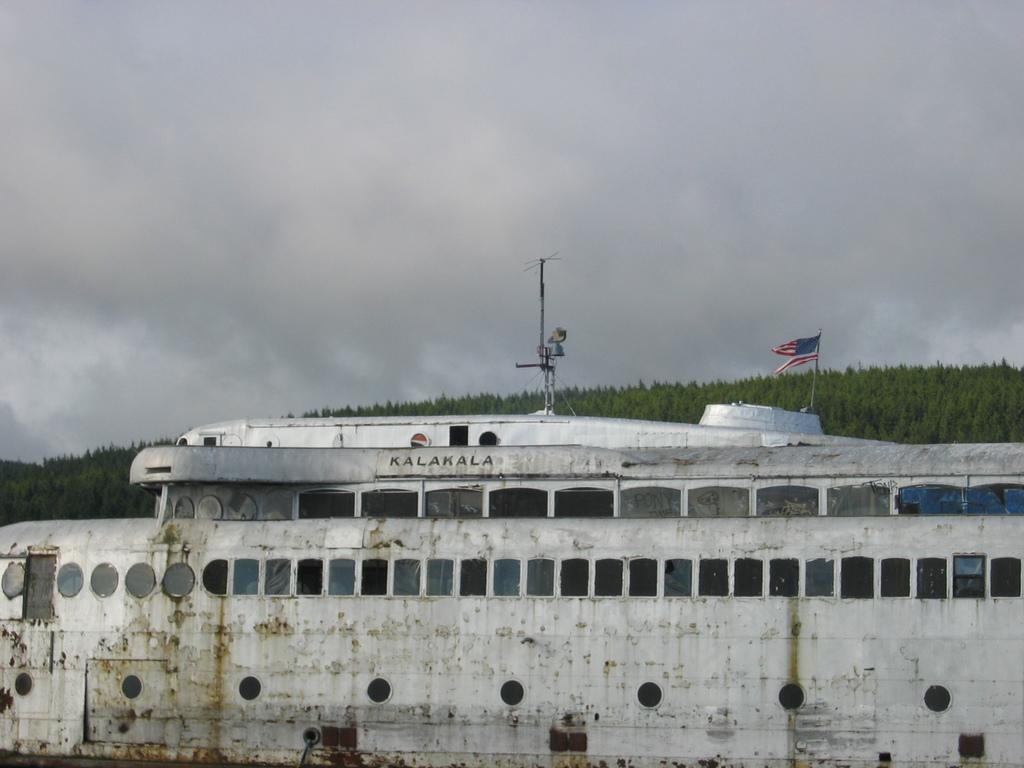What is the main subject of the image? There is a ship in the image. What is the color of the ship? The ship is white in color. Are there any specific features on the ship? Yes, there is a pole on the ship. What is attached to the pole? There is a flag on the pole. What can be seen in the background of the image? There are many trees in the background of the image, and the sky is cloudy. What type of harmony can be seen between the ship and the trees in the image? There is no indication of harmony between the ship and the trees in the image. --- Facts: 1. There is a car in the image. 2. The car is red. 3. The car has four wheels. 4. There is a person standing next to the car. 5. The person is holding a phone. Absurd Topics: unicorn, rainbow, umbrella Conversation: What is the main subject of the image? There is a car in the image. What color is the car? The car is red. How many wheels does the car have? The car has four wheels. Is there anyone else in the image besides the car? Yes, there is a person standing next to the car. What is the person doing in the image? The person is holding a phone. Reasoning: Let's think step by step in order to produce the conversation. We start by identifying the main subject of the image, which is the car. Next, we describe specific features of the car, such as its color and the number of wheels it has. Then, we observe the actions of the person in the image, noting that they are holding a phone. Absurd Question/Answer: Can you see a unicorn in the image? No, there is no unicorn present in the image. --- Facts: 1. There is a group of people in the image. 2. The people are wearing costumes. 3. The costumes are of animals. 4. There is a stage in the background. 5. The people are holding musical instruments. Absurd Topics: circus tent, elephant, juggling Conversation: How many people are in the image? There is a group of people in the image. What are the people wearing in the image? The people are wearing costumes. What type of costumes are the people wearing? The costumes are of animals. Can you describe the background of the image? Yes, there is a stage in the background. What are the people doing in the image? The people are holding musical instruments. Reasoning: Let's think step by step in order to produce the conversation. We start by identifying the main subject of the image, which is the group of people. Next, we describe the 